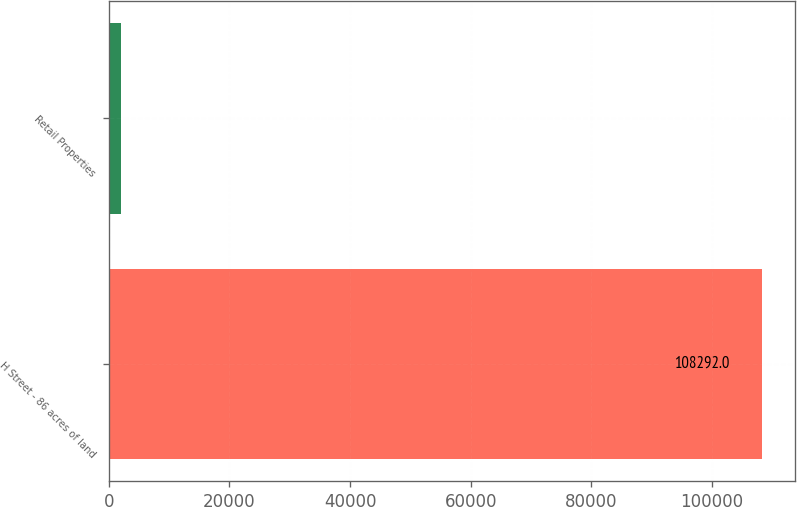Convert chart. <chart><loc_0><loc_0><loc_500><loc_500><bar_chart><fcel>H Street - 86 acres of land<fcel>Retail Properties<nl><fcel>108292<fcel>2088<nl></chart> 